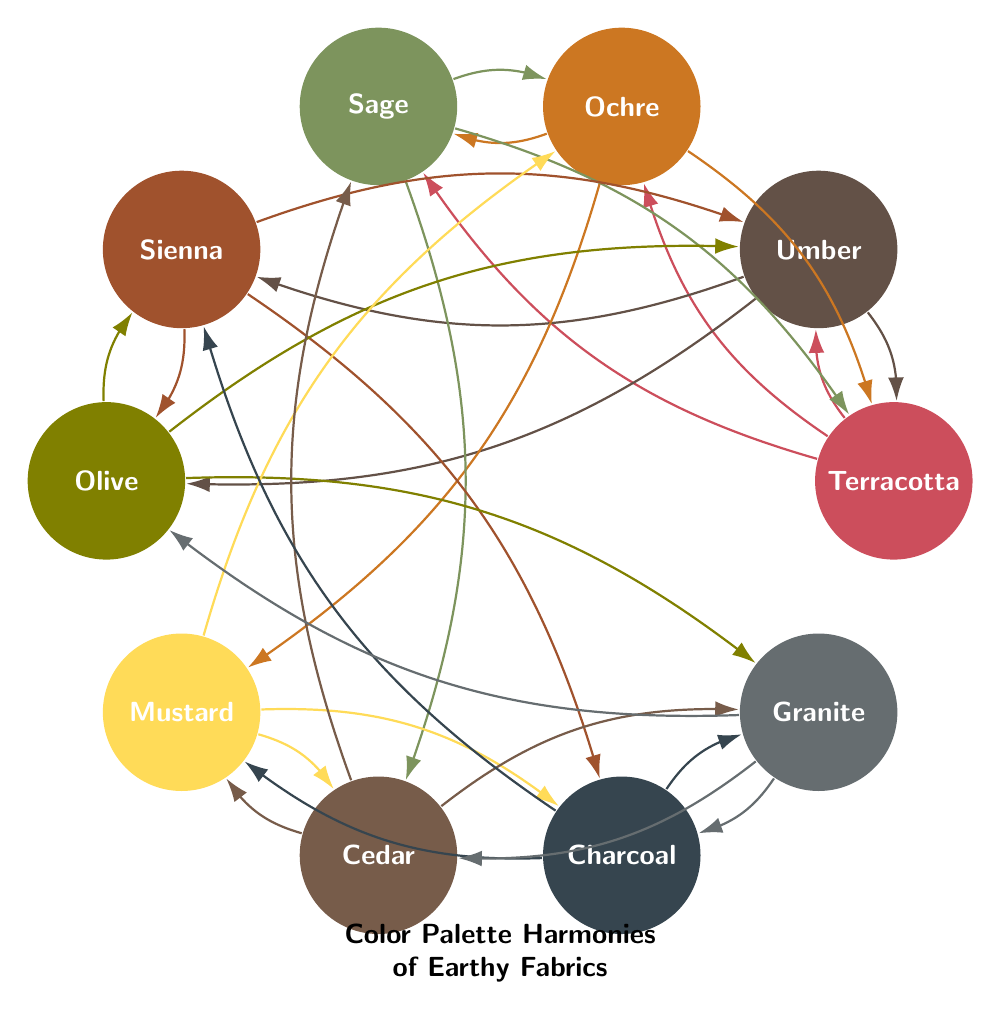What colors harmonize with Terracotta? Looking at the edges connected to the Terracotta node in the diagram, the colors Umber, Ochre, and Sage are directly linked, indicating that they harmonize with Terracotta.
Answer: Umber, Ochre, Sage How many colors are in this diagram? The diagram displays a total of ten unique colors: Terracotta, Umber, Ochre, Sage, Sienna, Olive, Mustard, Cedar, Charcoal, and Granite.
Answer: 10 Which color is connected to Olive? In the diagram, the Olive node has edges that connect it to three colors: Umber, Sienna, and Granite. Therefore, all these colors can be considered connected to Olive.
Answer: Umber, Sienna, Granite What is the relationship between Ochre and Mustard? The arrows in the diagram show a direct connection indicating that Ochre harmonizes with Mustard, reflecting a harmonious relationship between these two colors.
Answer: Ochre harmonizes with Mustard Which color has the most connections? By examining each node, we can see how many edges connect to it. The colors with three connections include Terracotta, Umber, Ochre, Sage, Sienna, and Mustard—all having the same number of connections. However, all of them could be considered to equally have the most connections based on the data.
Answer: Terracotta, Umber, Ochre, Sage, Sienna, Mustard Are there any colors that only connect to one color? Upon inspection of the diagram, each color has more than one outgoing edge. Therefore, no colors are limited to a single connection.
Answer: No Which two colors have overlapping harmonies? Reviewing the connections, it's evident that both Umber and Olive share a harmonizing connection with Sienna, demonstrating overlapping harmonies among these colors.
Answer: Umber and Olive share Sienna What color is most popular based on harmonies? By counting the incoming connections, we can determine that the colors like Terracotta, Umber, or Ochre have the most incoming edges from other colors, suggesting they are popular within this palette.
Answer: Terracotta, Umber, Ochre What does the diagram represent? The diagram visualizes the harmonic relationships between various earthy colors, showing how they connect and correspond with each other in a color palette specifically designed for rustic-inspired interiors.
Answer: Color Palette Harmonies of Earthy Fabrics 